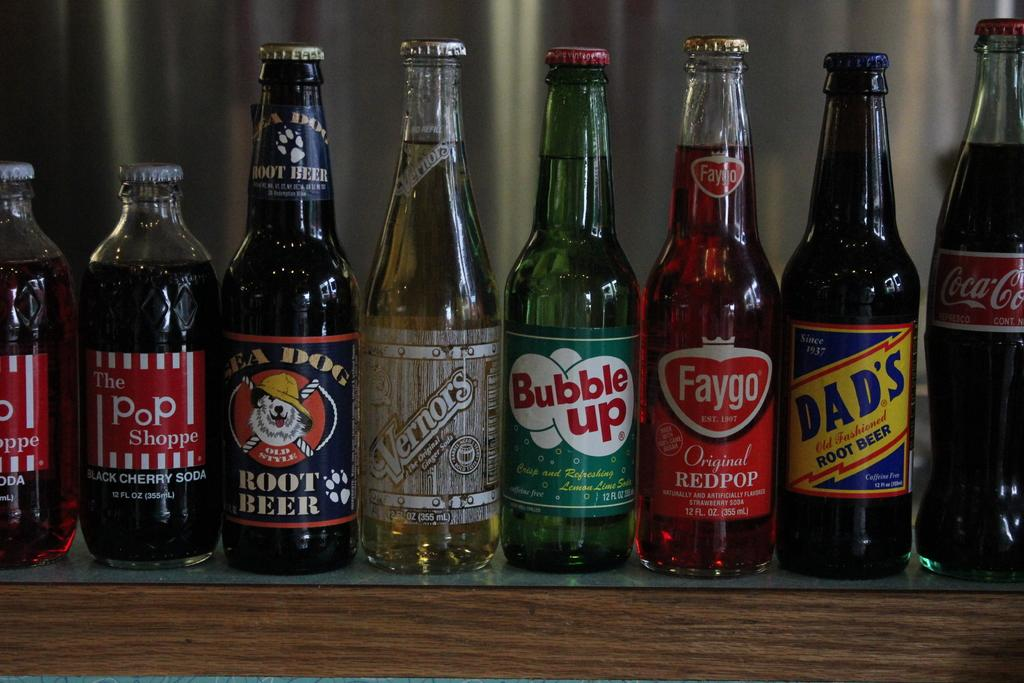<image>
Provide a brief description of the given image. A row of soda bottles including Dad's root beer and Bubble Up. 